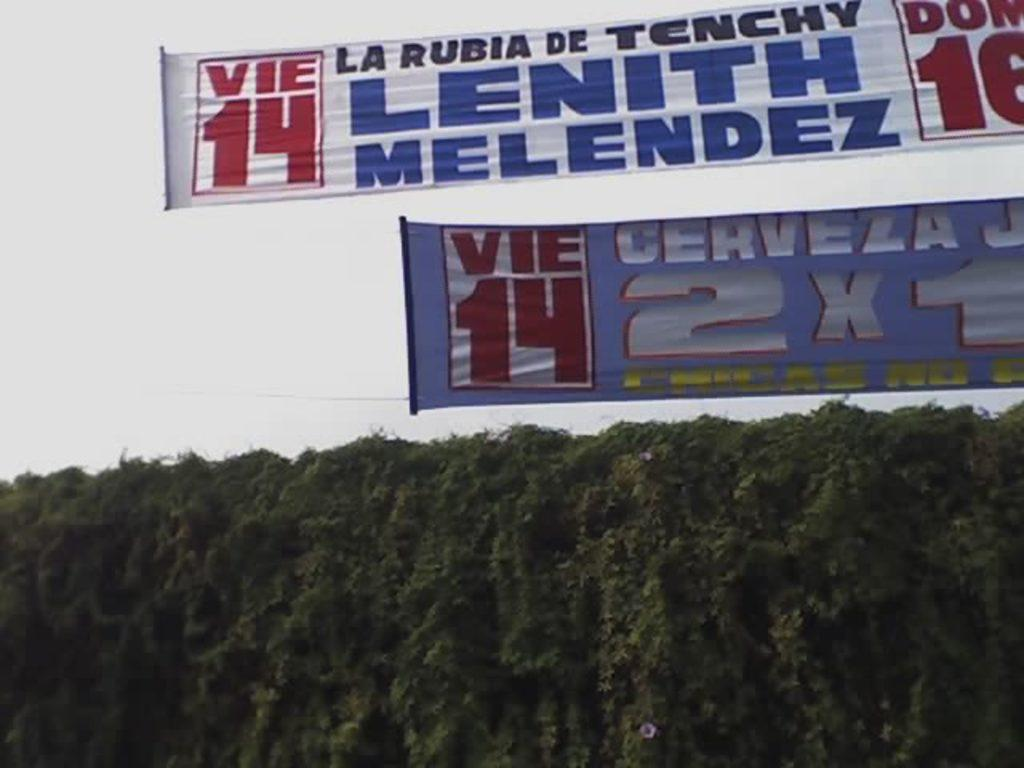What type of vegetation is at the bottom of the image? There are trees at the bottom of the image. What decorative elements are at the top of the image? There are banners at the top of the image. What can be seen behind the banners in the image? The sky is visible behind the banners. Can you see a monkey holding a pen in the image? No, there is no monkey or pen present in the image. 